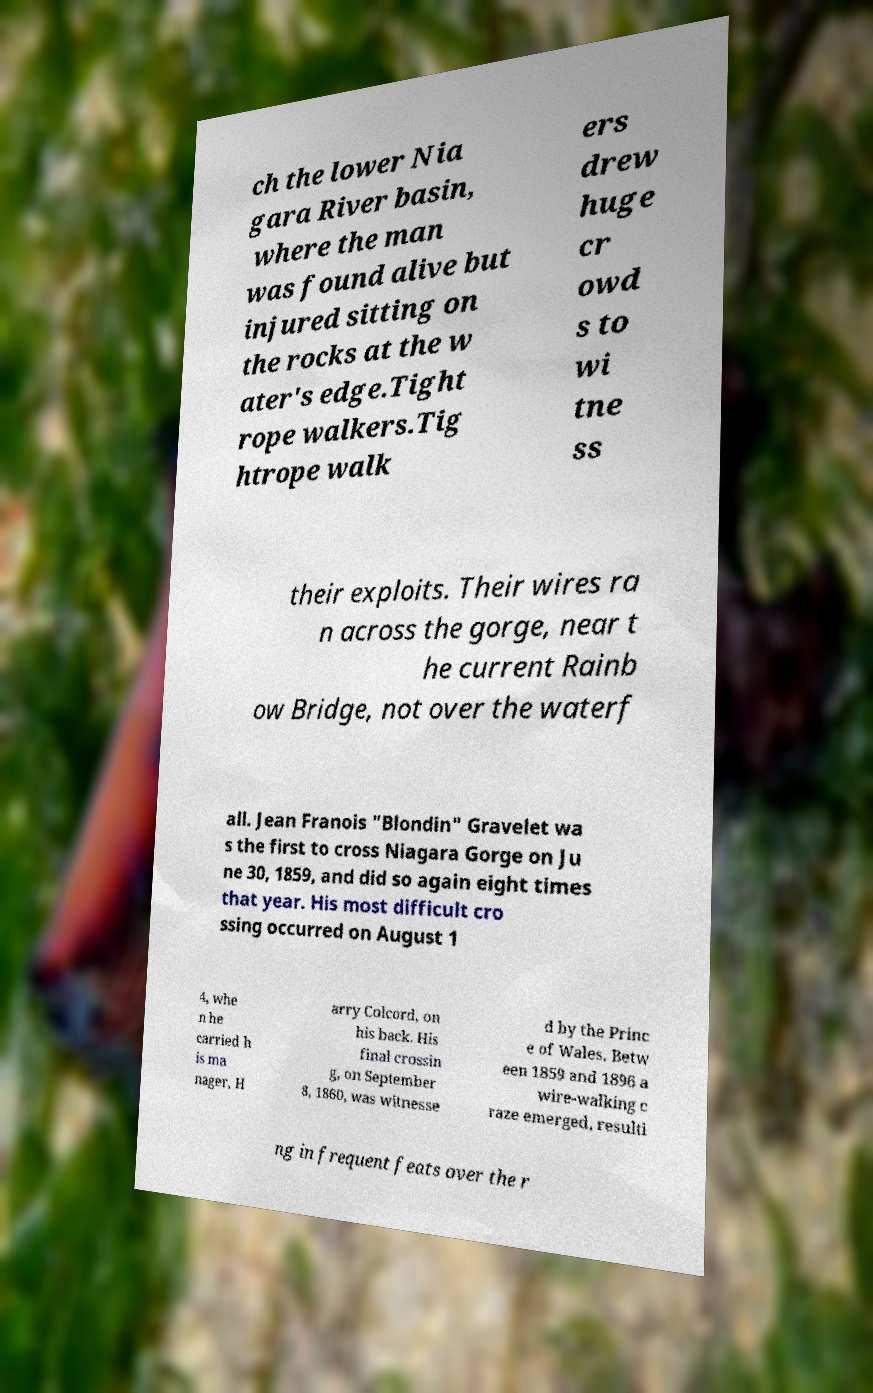For documentation purposes, I need the text within this image transcribed. Could you provide that? ch the lower Nia gara River basin, where the man was found alive but injured sitting on the rocks at the w ater's edge.Tight rope walkers.Tig htrope walk ers drew huge cr owd s to wi tne ss their exploits. Their wires ra n across the gorge, near t he current Rainb ow Bridge, not over the waterf all. Jean Franois "Blondin" Gravelet wa s the first to cross Niagara Gorge on Ju ne 30, 1859, and did so again eight times that year. His most difficult cro ssing occurred on August 1 4, whe n he carried h is ma nager, H arry Colcord, on his back. His final crossin g, on September 8, 1860, was witnesse d by the Princ e of Wales. Betw een 1859 and 1896 a wire-walking c raze emerged, resulti ng in frequent feats over the r 